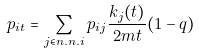<formula> <loc_0><loc_0><loc_500><loc_500>p _ { i t } = \sum _ { j \in n . n . i } p _ { i j } \frac { k _ { j } ( t ) } { 2 m t } ( 1 - q )</formula> 